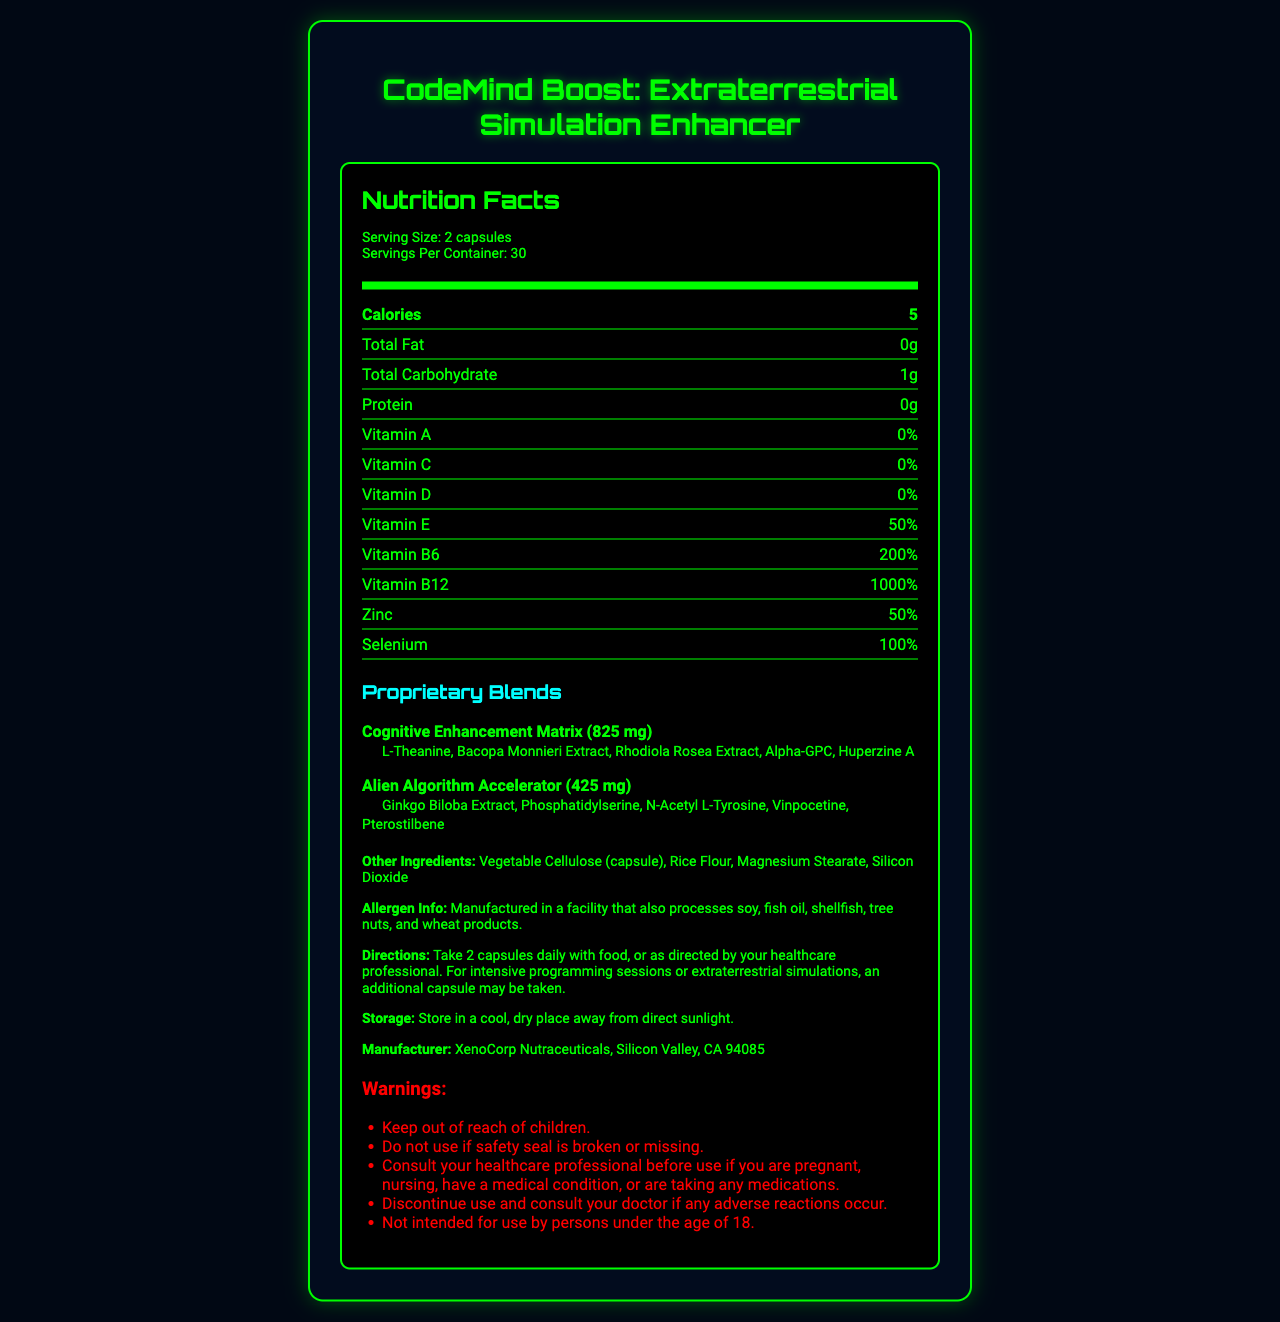what is the serving size? The serving size is mentioned as "2 capsules" under the serving information.
Answer: 2 capsules how many servings are there per container? The product provides 30 servings per container, as indicated beneath the serving size information.
Answer: 30 how many calories are in each serving? The document shows that there are 5 calories per serving.
Answer: 5 what percentage of Vitamin E is provided per serving? The label states that each serving offers 50% of the daily value for Vitamin E.
Answer: 50% which proprietary blend includes L-Theanine? L-Theanine is listed as an ingredient in the Cognitive Enhancement Matrix.
Answer: Cognitive Enhancement Matrix which city is XenoCorp Nutraceuticals located in? The manufacturer, XenoCorp Nutraceuticals, is located in Silicon Valley, California.
Answer: Silicon Valley, CA which vitamin has the highest percentage daily value? A. Vitamin B12 B. Vitamin E C. Vitamin B6 D. Folate Vitamin B12 has a daily value percentage of 1000%, which is higher than the other vitamins listed.
Answer: A. Vitamin B12 which ingredients are part of the Cognitive Enhancement Matrix? I. L-Theanine II. Alpha-GPC III. Pterostilbene A. I only B. I and II only C. II and III only D. I, II, and III The Cognitive Enhancement Matrix contains L-Theanine and Alpha-GPC but not Pterostilbene.
Answer: B. I and II only should children use this supplement? The warnings clearly state that it is not intended for use by persons under the age of 18.
Answer: No is there any fat content in this supplement? The total fat content is listed as 0 grams.
Answer: No describe the main idea of the document. This label gives comprehensive information about the supplement, focusing on enhancing cognitive functions for complex programming tasks.
Answer: The document is a Nutrition Facts label for a vitamin supplement called "CodeMind Boost: Extraterrestrial Simulation Enhancer." It provides details about serving size, nutritional information, proprietary blends, other ingredients, allergen information, directions, warnings, storage instructions, and manufacturer details. what is the source of Biotin in the supplement? The document does not specify the source of Biotin or other specific nutrient sources.
Answer: Cannot be determined 